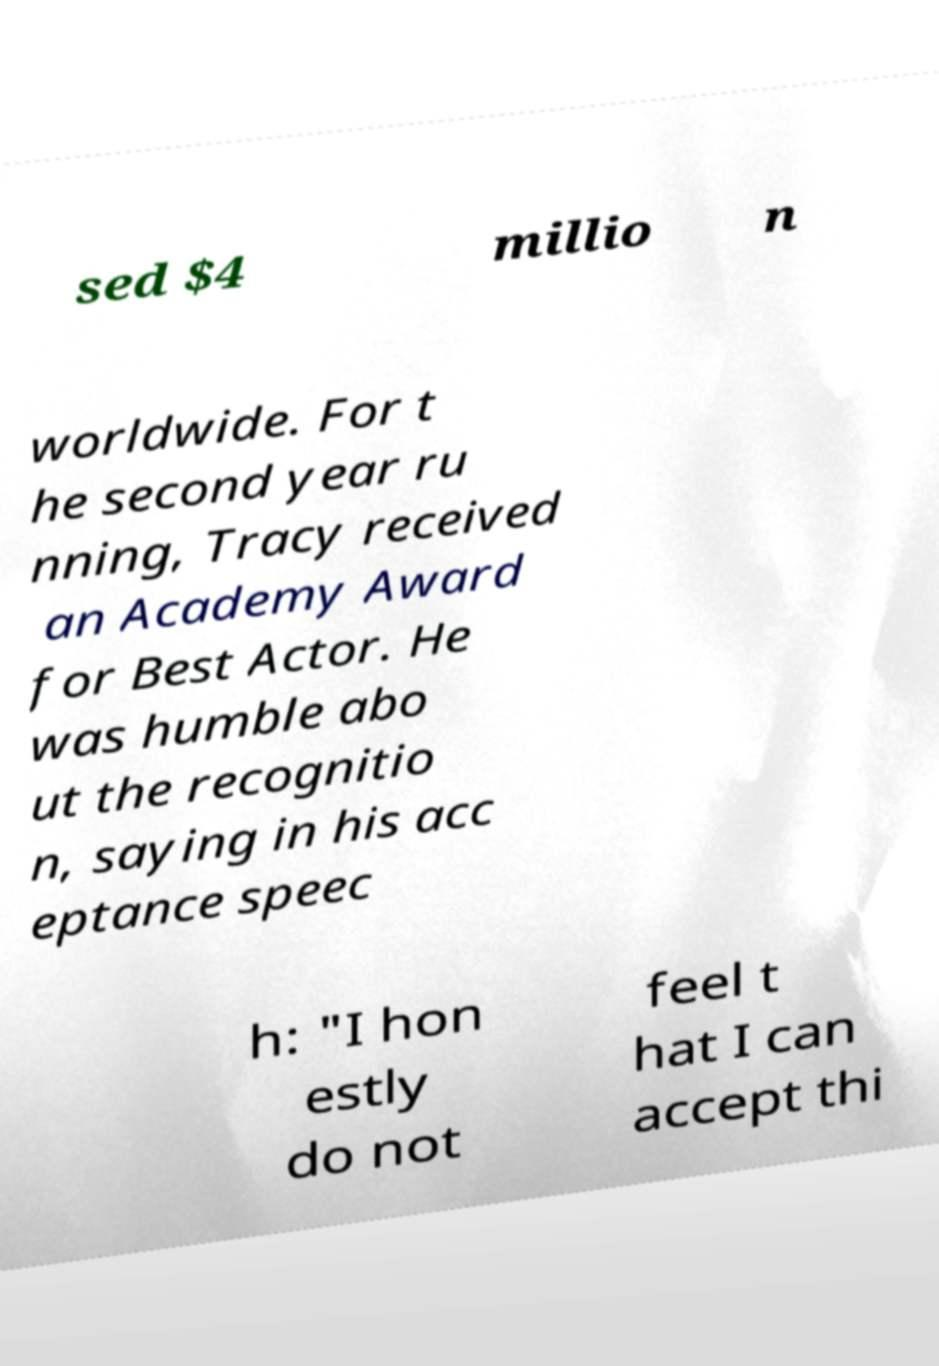For documentation purposes, I need the text within this image transcribed. Could you provide that? sed $4 millio n worldwide. For t he second year ru nning, Tracy received an Academy Award for Best Actor. He was humble abo ut the recognitio n, saying in his acc eptance speec h: "I hon estly do not feel t hat I can accept thi 